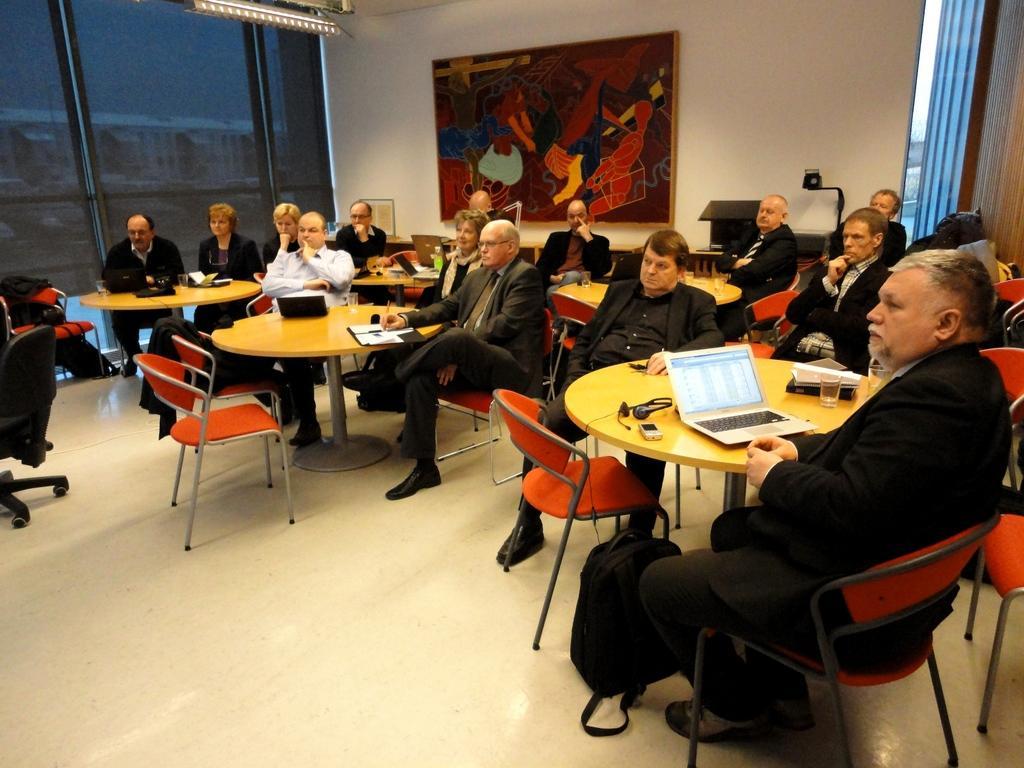How would you summarize this image in a sentence or two? In this image, we can see a group of people are sitting on the chairs. Here we can see few tables, chairs. Few objects and things are placed on it. At the bottom, there is a floor. Background we can see a wall, decorative piece, glass windows, shades, light, some objects. 